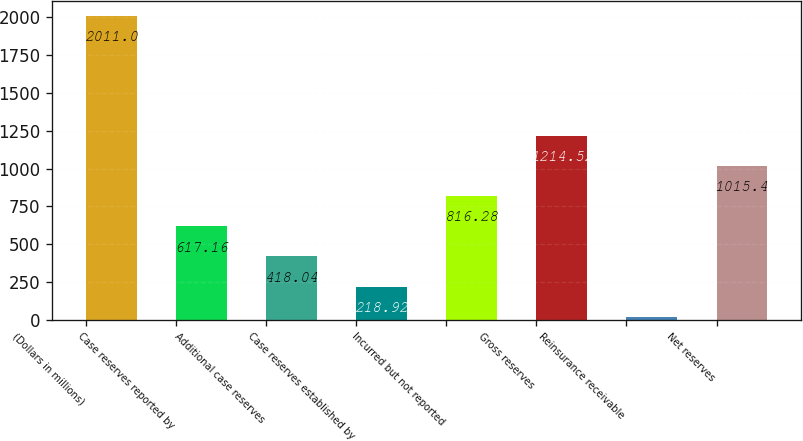<chart> <loc_0><loc_0><loc_500><loc_500><bar_chart><fcel>(Dollars in millions)<fcel>Case reserves reported by<fcel>Additional case reserves<fcel>Case reserves established by<fcel>Incurred but not reported<fcel>Gross reserves<fcel>Reinsurance receivable<fcel>Net reserves<nl><fcel>2011<fcel>617.16<fcel>418.04<fcel>218.92<fcel>816.28<fcel>1214.52<fcel>19.8<fcel>1015.4<nl></chart> 